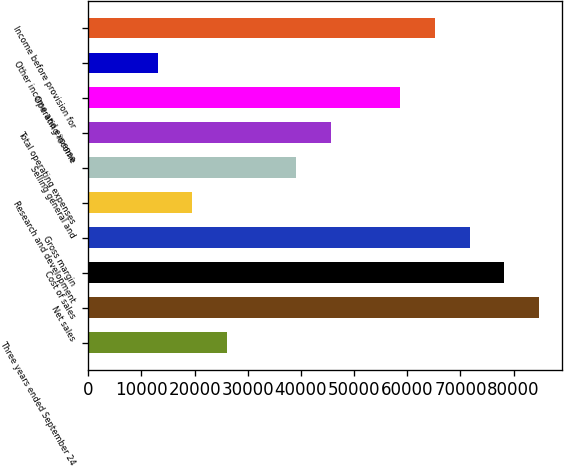Convert chart to OTSL. <chart><loc_0><loc_0><loc_500><loc_500><bar_chart><fcel>Three years ended September 24<fcel>Net sales<fcel>Cost of sales<fcel>Gross margin<fcel>Research and development<fcel>Selling general and<fcel>Total operating expenses<fcel>Operating income<fcel>Other income and expense<fcel>Income before provision for<nl><fcel>26099.1<fcel>84788<fcel>78267<fcel>71746<fcel>19578.1<fcel>39141.1<fcel>45662.1<fcel>58704<fcel>13057.1<fcel>65225<nl></chart> 